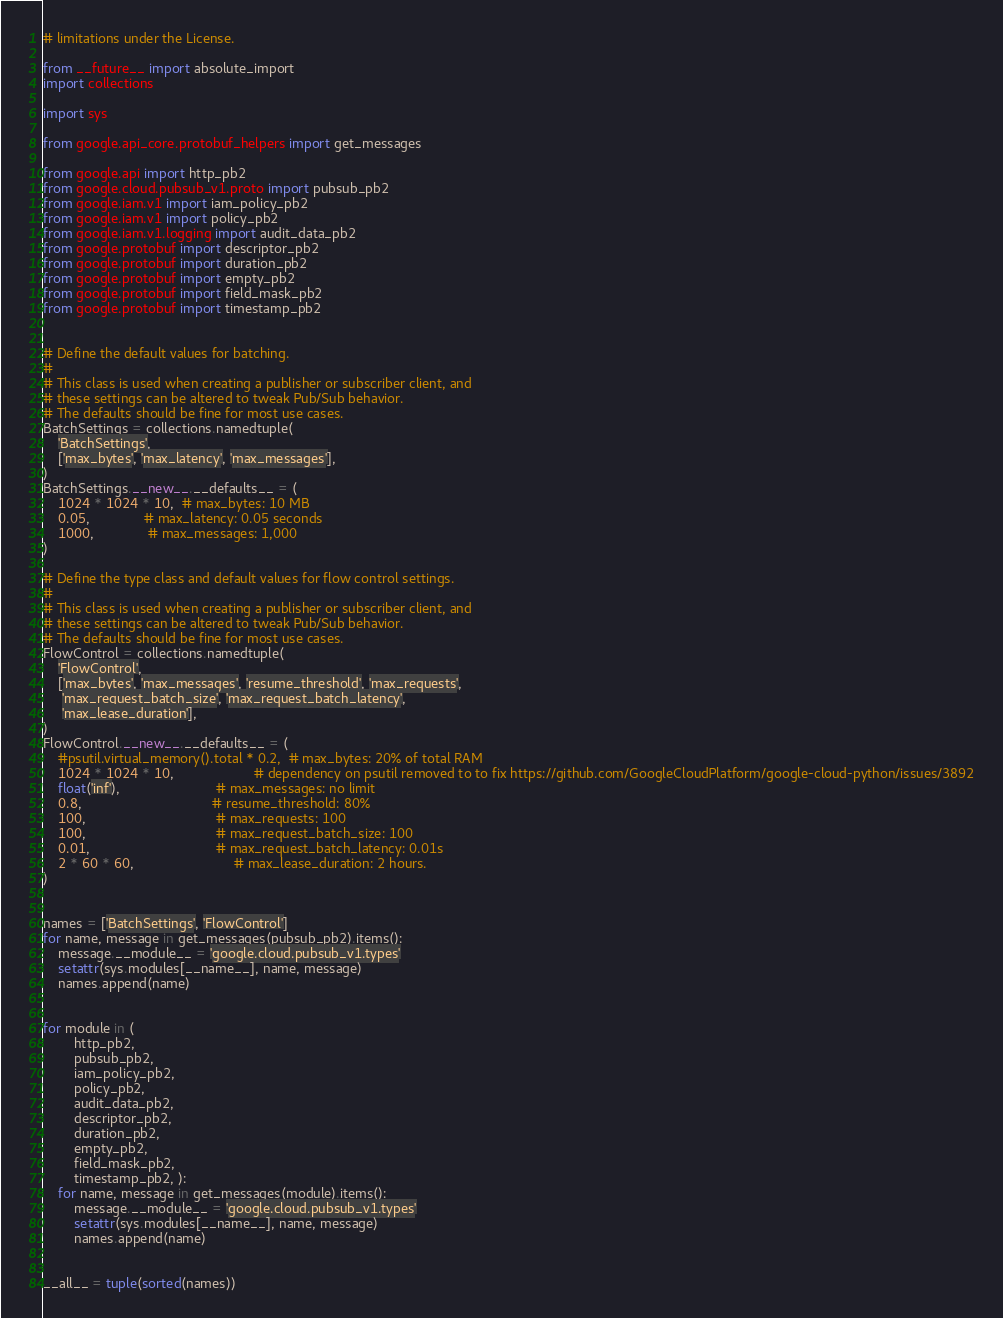Convert code to text. <code><loc_0><loc_0><loc_500><loc_500><_Python_># limitations under the License.

from __future__ import absolute_import
import collections

import sys

from google.api_core.protobuf_helpers import get_messages

from google.api import http_pb2
from google.cloud.pubsub_v1.proto import pubsub_pb2
from google.iam.v1 import iam_policy_pb2
from google.iam.v1 import policy_pb2
from google.iam.v1.logging import audit_data_pb2
from google.protobuf import descriptor_pb2
from google.protobuf import duration_pb2
from google.protobuf import empty_pb2
from google.protobuf import field_mask_pb2
from google.protobuf import timestamp_pb2


# Define the default values for batching.
#
# This class is used when creating a publisher or subscriber client, and
# these settings can be altered to tweak Pub/Sub behavior.
# The defaults should be fine for most use cases.
BatchSettings = collections.namedtuple(
    'BatchSettings',
    ['max_bytes', 'max_latency', 'max_messages'],
)
BatchSettings.__new__.__defaults__ = (
    1024 * 1024 * 10,  # max_bytes: 10 MB
    0.05,              # max_latency: 0.05 seconds
    1000,              # max_messages: 1,000
)

# Define the type class and default values for flow control settings.
#
# This class is used when creating a publisher or subscriber client, and
# these settings can be altered to tweak Pub/Sub behavior.
# The defaults should be fine for most use cases.
FlowControl = collections.namedtuple(
    'FlowControl',
    ['max_bytes', 'max_messages', 'resume_threshold', 'max_requests',
     'max_request_batch_size', 'max_request_batch_latency',
     'max_lease_duration'],
)
FlowControl.__new__.__defaults__ = (
    #psutil.virtual_memory().total * 0.2,  # max_bytes: 20% of total RAM
    1024 * 1024 * 10,                     # dependency on psutil removed to to fix https://github.com/GoogleCloudPlatform/google-cloud-python/issues/3892
    float('inf'),                         # max_messages: no limit
    0.8,                                  # resume_threshold: 80%
    100,                                  # max_requests: 100
    100,                                  # max_request_batch_size: 100
    0.01,                                 # max_request_batch_latency: 0.01s
    2 * 60 * 60,                          # max_lease_duration: 2 hours.
)


names = ['BatchSettings', 'FlowControl']
for name, message in get_messages(pubsub_pb2).items():
    message.__module__ = 'google.cloud.pubsub_v1.types'
    setattr(sys.modules[__name__], name, message)
    names.append(name)


for module in (
        http_pb2,
        pubsub_pb2,
        iam_policy_pb2,
        policy_pb2,
        audit_data_pb2,
        descriptor_pb2,
        duration_pb2,
        empty_pb2,
        field_mask_pb2,
        timestamp_pb2, ):
    for name, message in get_messages(module).items():
        message.__module__ = 'google.cloud.pubsub_v1.types'
        setattr(sys.modules[__name__], name, message)
        names.append(name)


__all__ = tuple(sorted(names))
</code> 